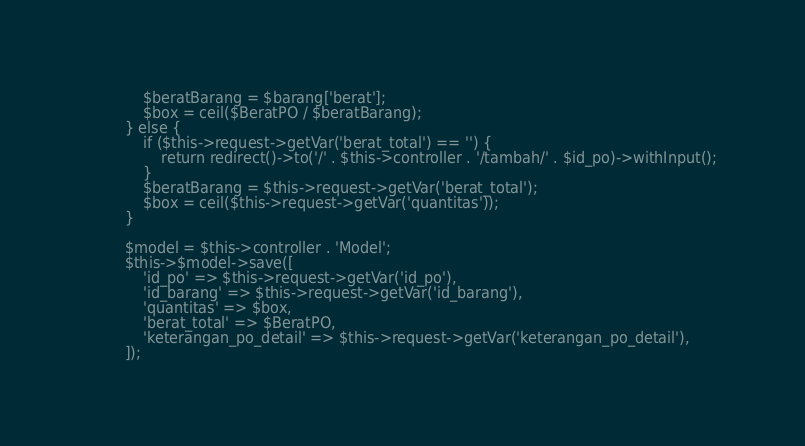Convert code to text. <code><loc_0><loc_0><loc_500><loc_500><_PHP_>            $beratBarang = $barang['berat'];
            $box = ceil($BeratPO / $beratBarang);
        } else {
            if ($this->request->getVar('berat_total') == '') {
                return redirect()->to('/' . $this->controller . '/tambah/' . $id_po)->withInput();
            }
            $beratBarang = $this->request->getVar('berat_total');
            $box = ceil($this->request->getVar('quantitas'));
        }

        $model = $this->controller . 'Model';
        $this->$model->save([
            'id_po' => $this->request->getVar('id_po'),
            'id_barang' => $this->request->getVar('id_barang'),
            'quantitas' => $box,
            'berat_total' => $BeratPO,
            'keterangan_po_detail' => $this->request->getVar('keterangan_po_detail'),
        ]);</code> 